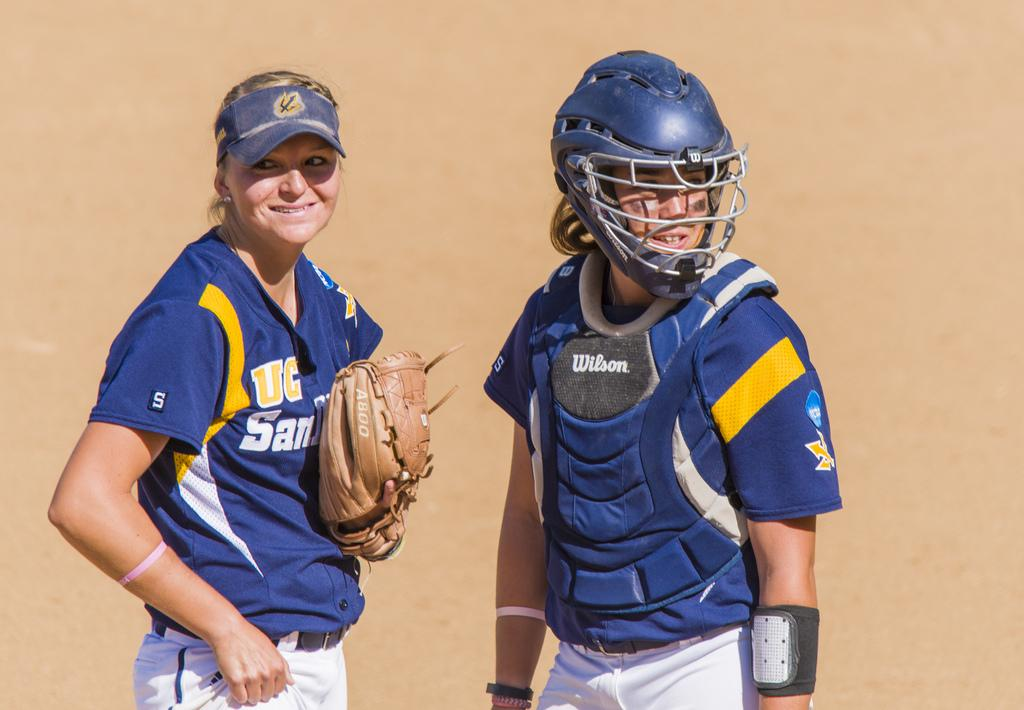<image>
Write a terse but informative summary of the picture. female softball players for uc san diego looking forward in the sunlight 